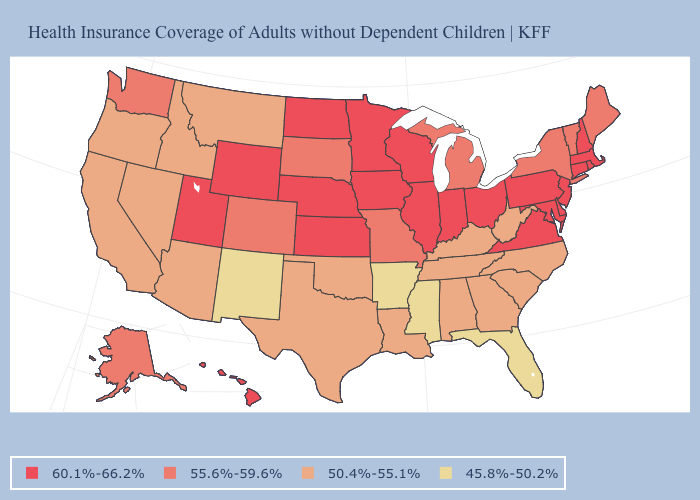What is the highest value in states that border Minnesota?
Give a very brief answer. 60.1%-66.2%. How many symbols are there in the legend?
Answer briefly. 4. What is the value of New Mexico?
Give a very brief answer. 45.8%-50.2%. Which states have the highest value in the USA?
Give a very brief answer. Connecticut, Delaware, Hawaii, Illinois, Indiana, Iowa, Kansas, Maryland, Massachusetts, Minnesota, Nebraska, New Hampshire, New Jersey, North Dakota, Ohio, Pennsylvania, Rhode Island, Utah, Virginia, Wisconsin, Wyoming. What is the value of Oregon?
Keep it brief. 50.4%-55.1%. Is the legend a continuous bar?
Quick response, please. No. What is the lowest value in the Northeast?
Concise answer only. 55.6%-59.6%. Name the states that have a value in the range 60.1%-66.2%?
Quick response, please. Connecticut, Delaware, Hawaii, Illinois, Indiana, Iowa, Kansas, Maryland, Massachusetts, Minnesota, Nebraska, New Hampshire, New Jersey, North Dakota, Ohio, Pennsylvania, Rhode Island, Utah, Virginia, Wisconsin, Wyoming. Name the states that have a value in the range 50.4%-55.1%?
Answer briefly. Alabama, Arizona, California, Georgia, Idaho, Kentucky, Louisiana, Montana, Nevada, North Carolina, Oklahoma, Oregon, South Carolina, Tennessee, Texas, West Virginia. Does Indiana have a lower value than South Carolina?
Concise answer only. No. What is the value of Rhode Island?
Keep it brief. 60.1%-66.2%. Does Mississippi have the lowest value in the USA?
Give a very brief answer. Yes. Does Illinois have the highest value in the USA?
Write a very short answer. Yes. Is the legend a continuous bar?
Quick response, please. No. Which states have the lowest value in the USA?
Quick response, please. Arkansas, Florida, Mississippi, New Mexico. 